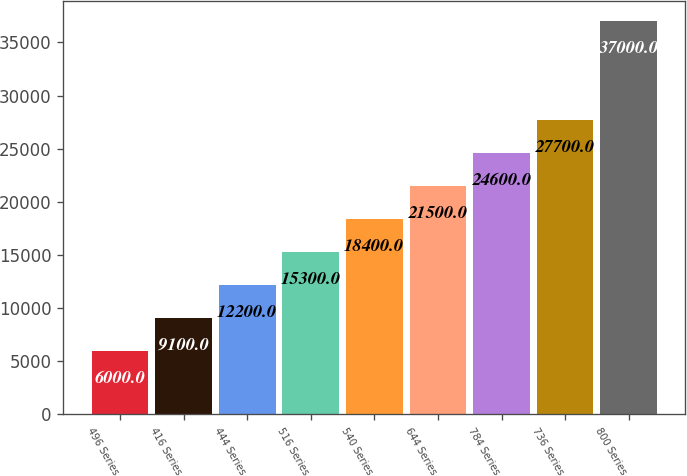Convert chart. <chart><loc_0><loc_0><loc_500><loc_500><bar_chart><fcel>496 Series<fcel>416 Series<fcel>444 Series<fcel>516 Series<fcel>540 Series<fcel>644 Series<fcel>784 Series<fcel>736 Series<fcel>800 Series<nl><fcel>6000<fcel>9100<fcel>12200<fcel>15300<fcel>18400<fcel>21500<fcel>24600<fcel>27700<fcel>37000<nl></chart> 